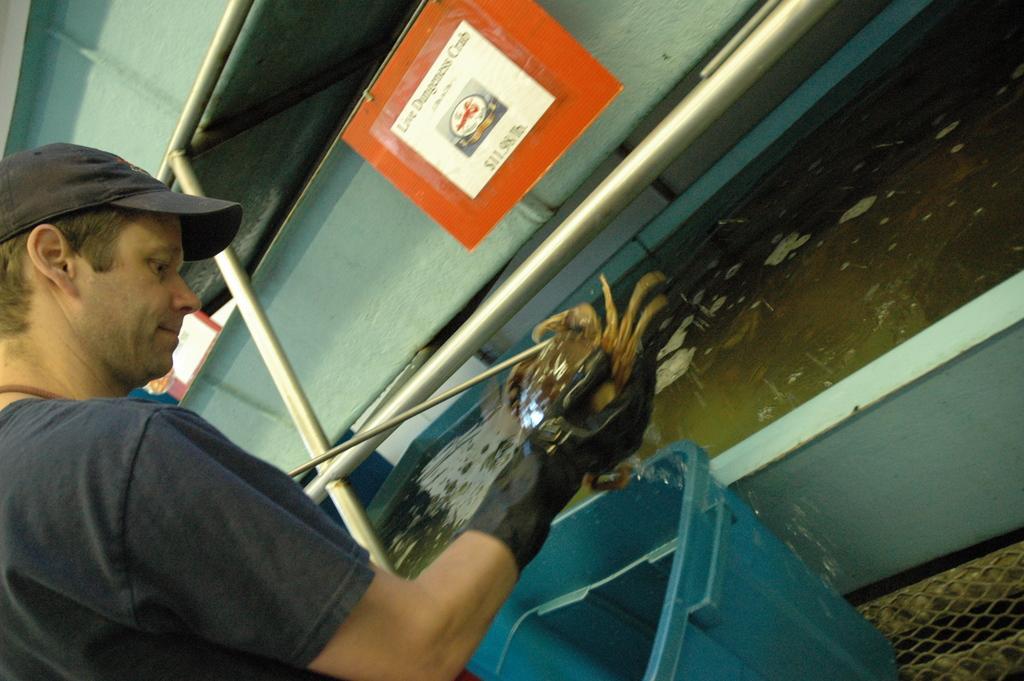Please provide a concise description of this image. There is one person standing and wearing a black color t shirt and holding an object on the left side of this image. There is a water container on the left side of this image, and there is a dustbin at the bottom of this image. There is a wall in the background. There is a poster as we can see at the top of this image. 